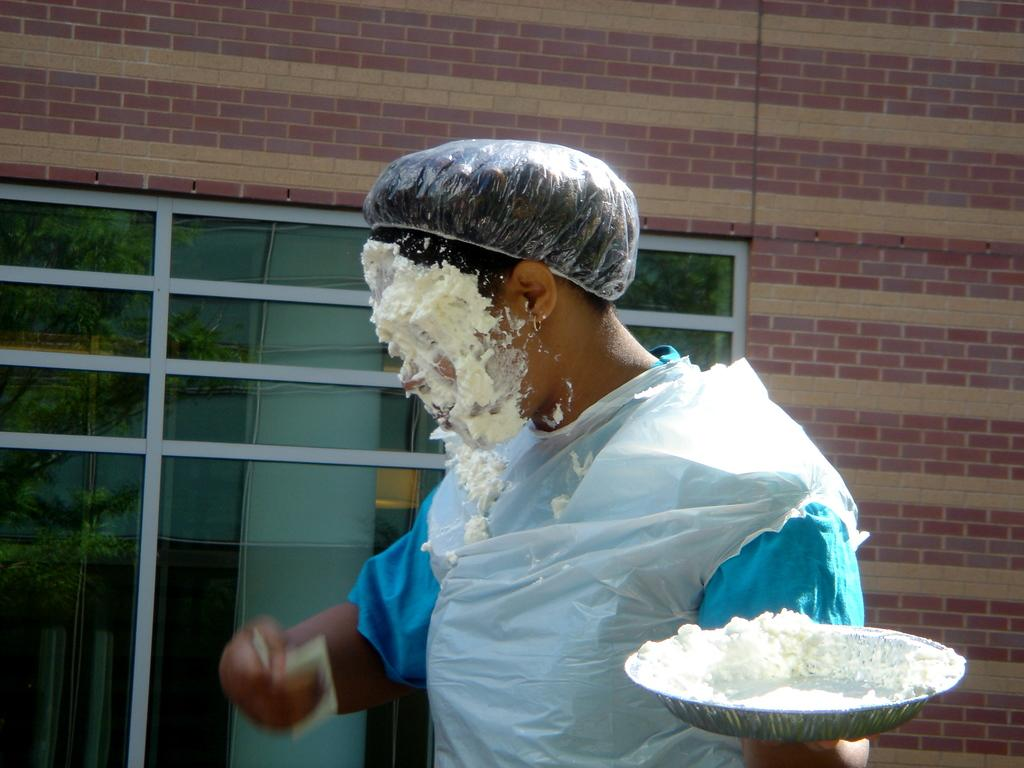What is the main subject of the image? There is a person in the image. What is the person holding in the image? The person is holding a bowl and an object in his hands. What can be seen in the background of the image? There is a wall with glass windows in the image, and trees are visible through the glass windows. What degree of difficulty does the mountain pose for the person in the image? There is no mountain present in the image. 